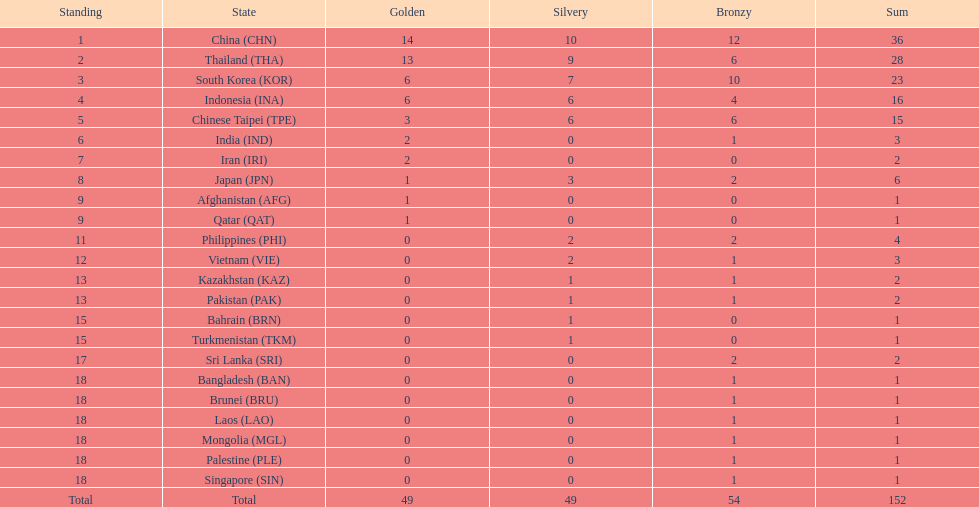Which countries achieved the same count of gold medals as japan? Afghanistan (AFG), Qatar (QAT). 